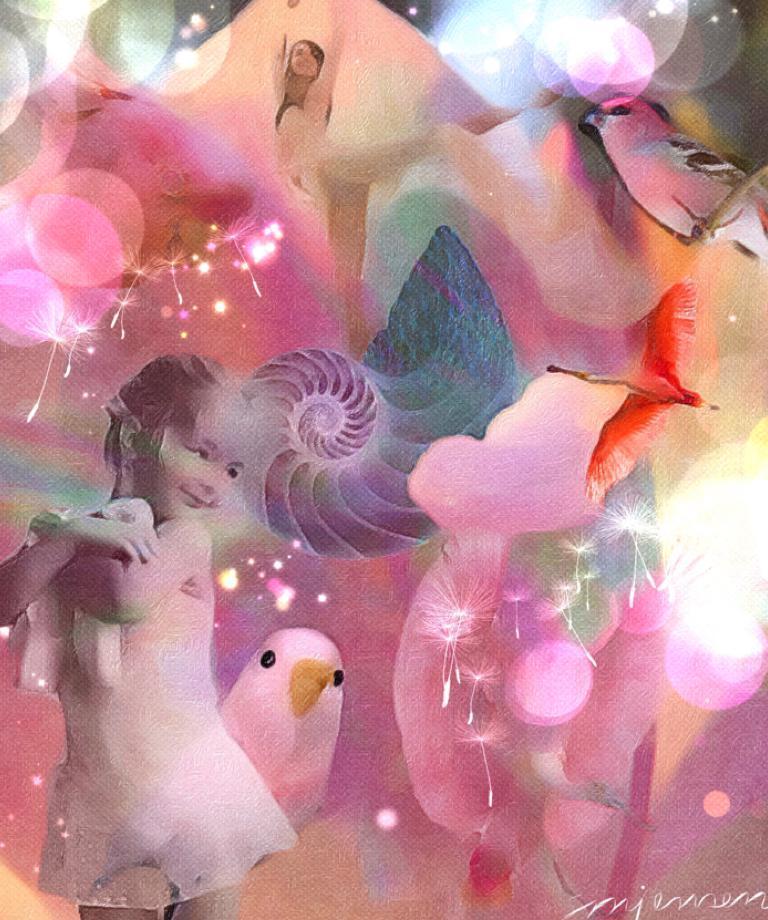Describe this image in one or two sentences. This image looks like it is edited. On the left, we can see a girl. And there are birds along with light effects. 